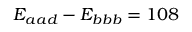Convert formula to latex. <formula><loc_0><loc_0><loc_500><loc_500>E _ { a a d } - E _ { b b b } = 1 0 8</formula> 